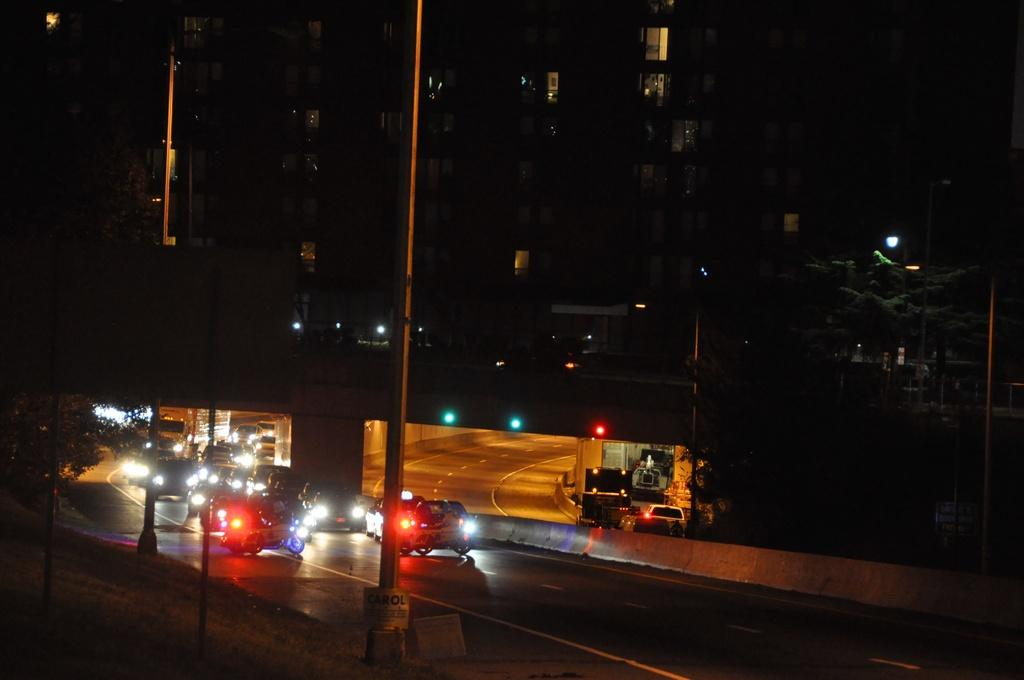What is happening at the bottom of the image? There are vehicles moving on the road in the image. What can be seen in the background of the image? There are buildings in the background of the image. What type of nail can be seen in the image? There is no nail present in the image. What is the material of the tin in the image? There is no tin present in the image. 